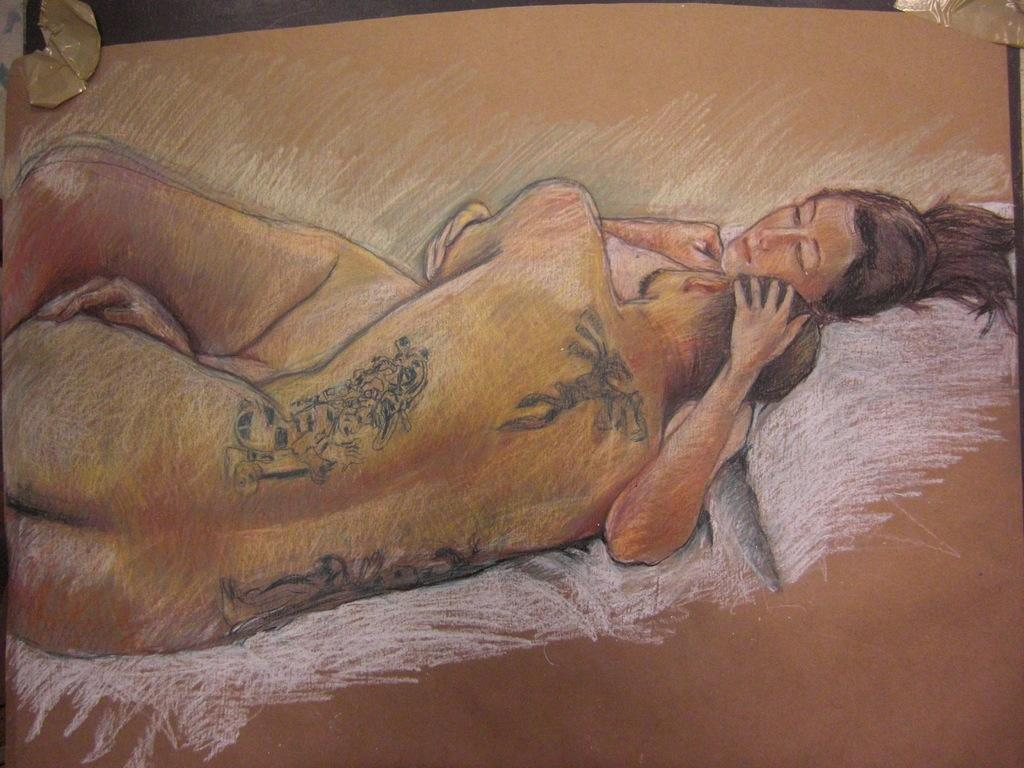What is the main subject of the image? The main subject of the image is a drawing. What does the drawing depict? The drawing depicts two persons. On what surface is the drawing made? The drawing is on a wooden board. What type of pain can be seen on the faces of the persons in the drawing? There is no indication of pain on the faces of the persons in the drawing; they are simply depicted as two individuals. 